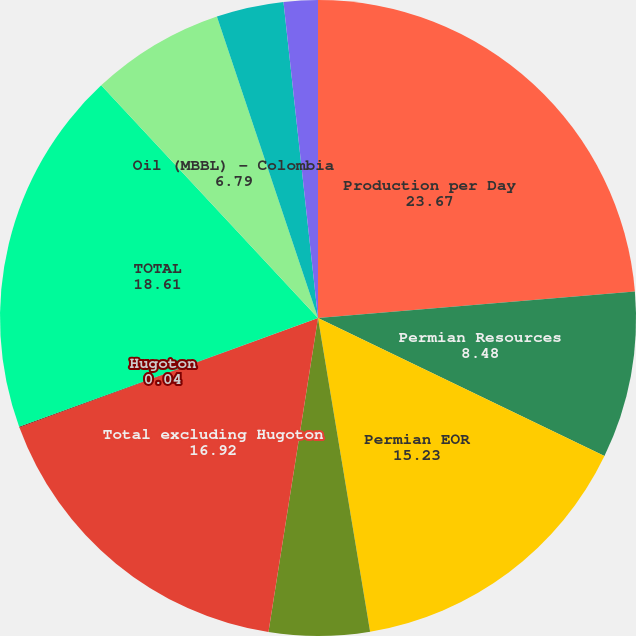Convert chart. <chart><loc_0><loc_0><loc_500><loc_500><pie_chart><fcel>Production per Day<fcel>Permian Resources<fcel>Permian EOR<fcel>Midcontinent and Other<fcel>Total excluding Hugoton<fcel>Hugoton<fcel>TOTAL<fcel>Oil (MBBL) - Colombia<fcel>Natural gas (MMCF) - Bolivia<fcel>Dolphin<nl><fcel>23.67%<fcel>8.48%<fcel>15.23%<fcel>5.11%<fcel>16.92%<fcel>0.04%<fcel>18.61%<fcel>6.79%<fcel>3.42%<fcel>1.73%<nl></chart> 